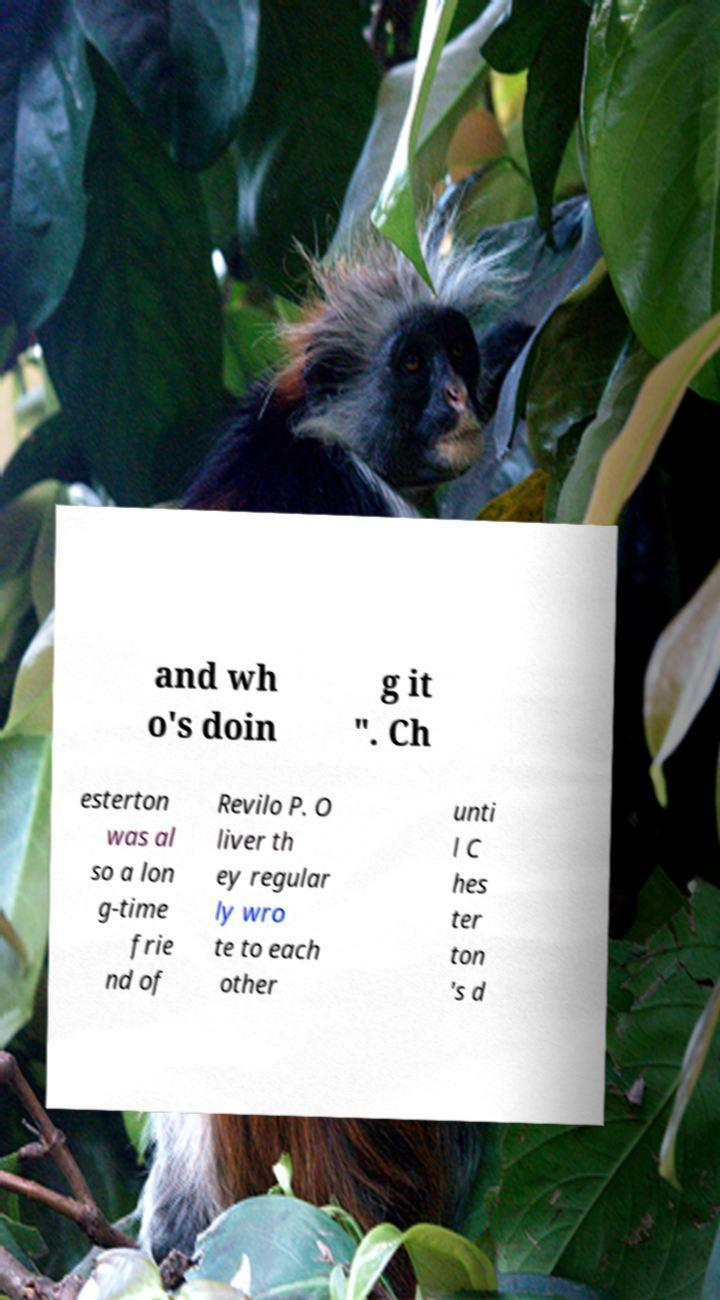Please read and relay the text visible in this image. What does it say? and wh o's doin g it ". Ch esterton was al so a lon g-time frie nd of Revilo P. O liver th ey regular ly wro te to each other unti l C hes ter ton 's d 